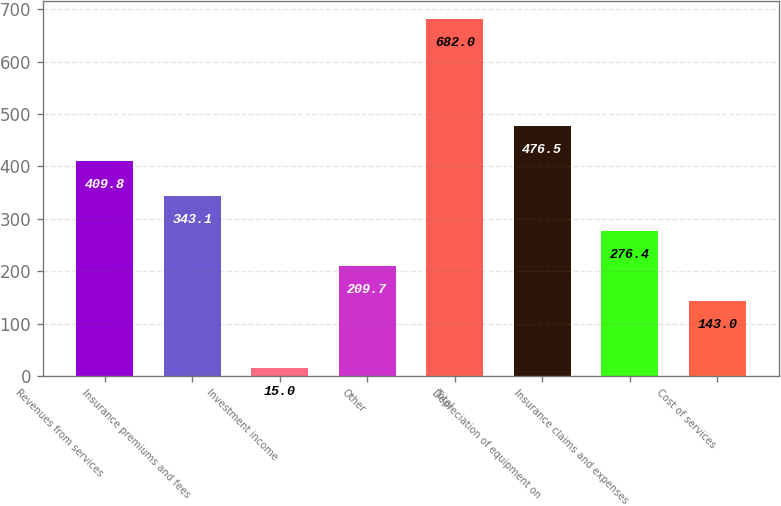<chart> <loc_0><loc_0><loc_500><loc_500><bar_chart><fcel>Revenues from services<fcel>Insurance premiums and fees<fcel>Investment income<fcel>Other<fcel>Total<fcel>Depreciation of equipment on<fcel>Insurance claims and expenses<fcel>Cost of services<nl><fcel>409.8<fcel>343.1<fcel>15<fcel>209.7<fcel>682<fcel>476.5<fcel>276.4<fcel>143<nl></chart> 